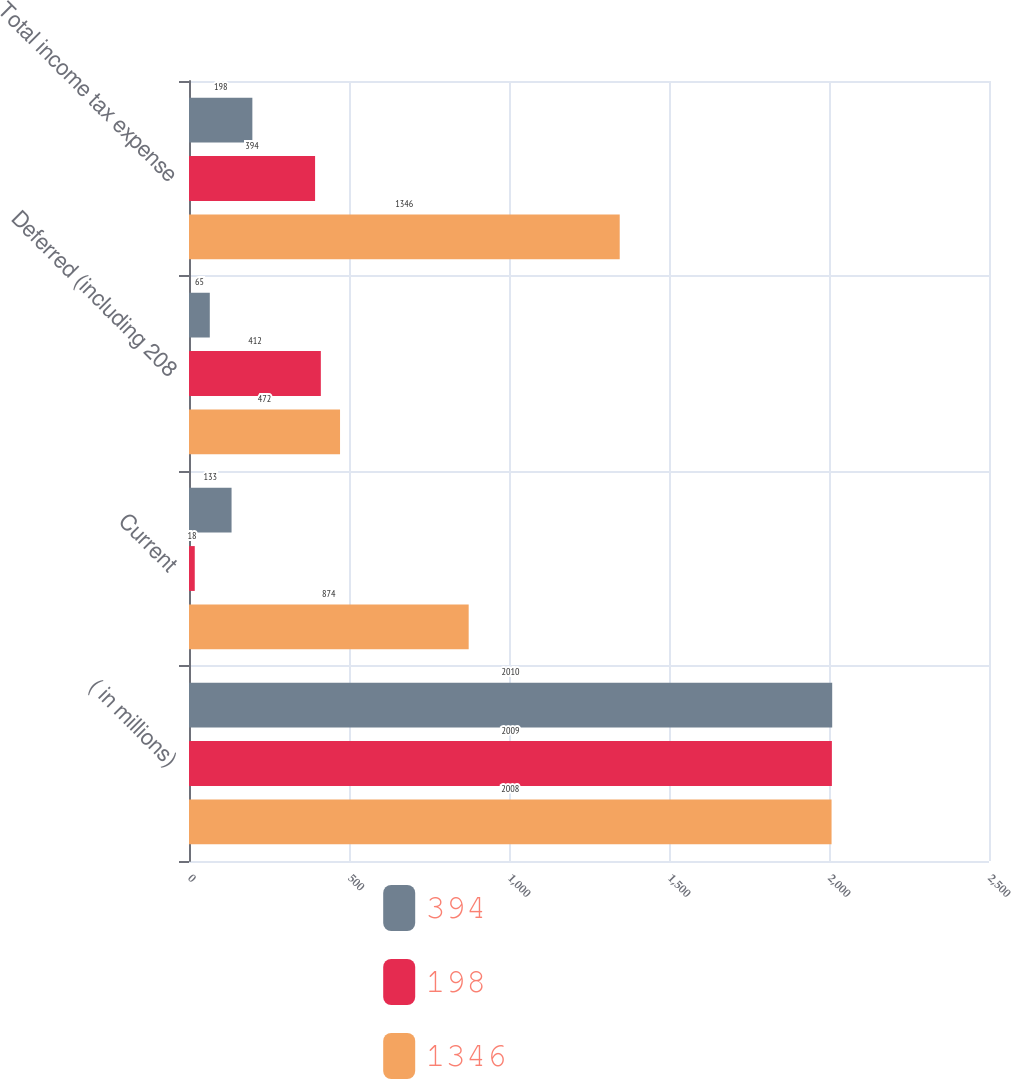Convert chart. <chart><loc_0><loc_0><loc_500><loc_500><stacked_bar_chart><ecel><fcel>( in millions)<fcel>Current<fcel>Deferred (including 208<fcel>Total income tax expense<nl><fcel>394<fcel>2010<fcel>133<fcel>65<fcel>198<nl><fcel>198<fcel>2009<fcel>18<fcel>412<fcel>394<nl><fcel>1346<fcel>2008<fcel>874<fcel>472<fcel>1346<nl></chart> 